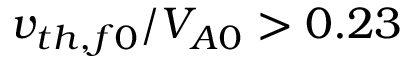Convert formula to latex. <formula><loc_0><loc_0><loc_500><loc_500>v _ { t h , f 0 } / V _ { A 0 } > 0 . 2 3</formula> 